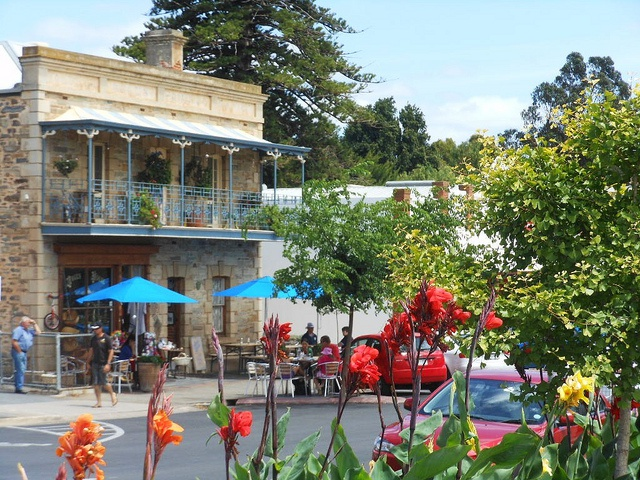Describe the objects in this image and their specific colors. I can see car in lightblue, darkgreen, gray, and black tones, car in lightblue, maroon, brown, black, and red tones, umbrella in lightblue tones, people in lightblue, black, and gray tones, and people in lightblue, gray, and darkgray tones in this image. 